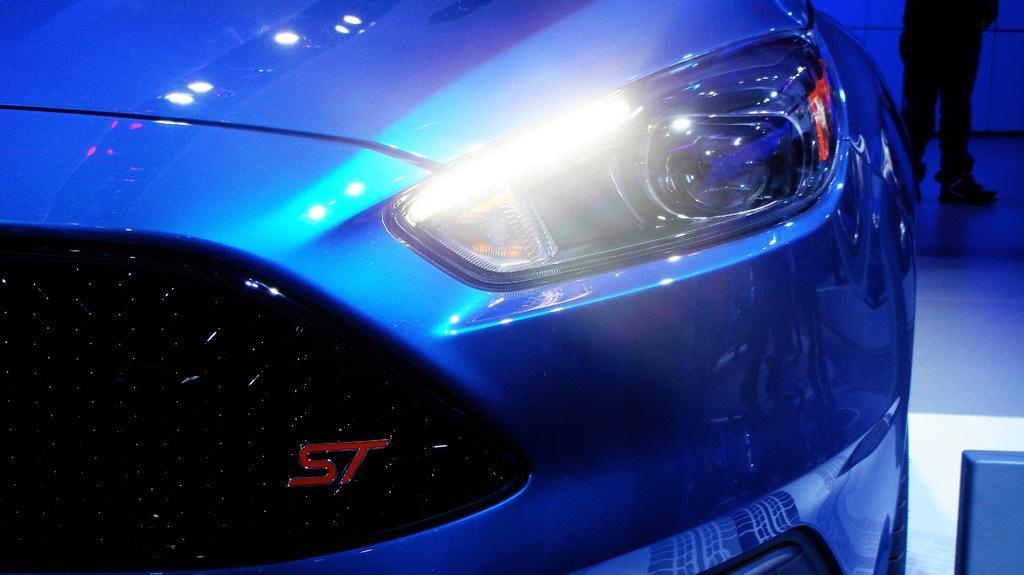Please provide a concise description of this image. In the image we can see a vehicle headlight. In the top right side of the image we can see legs of a person. 